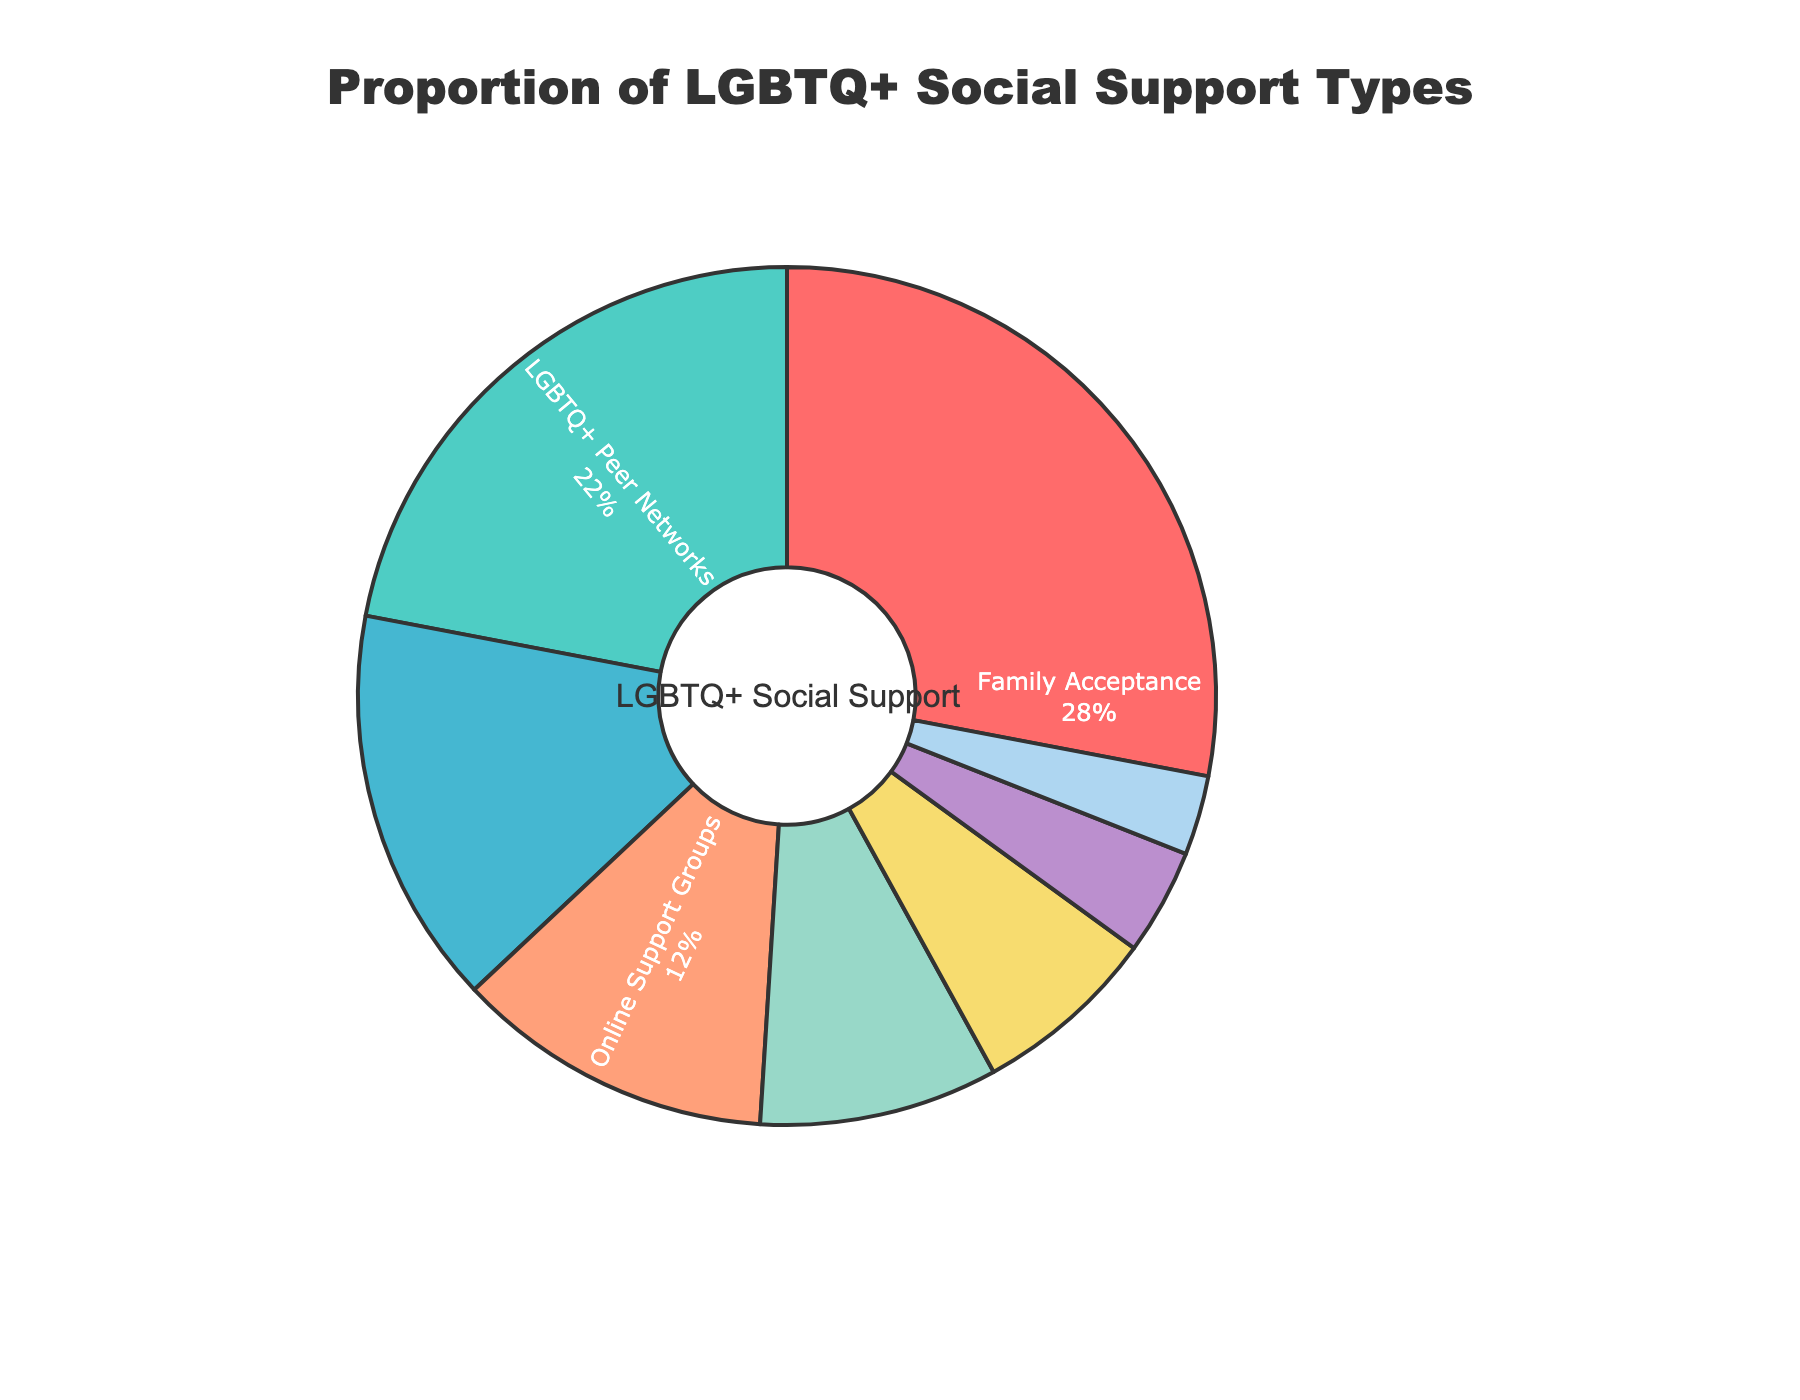What is the most common type of social support for LGBTQ+ individuals according to the pie chart? The slice of the pie chart representing "Family Acceptance" is the largest, indicating that it is the most prevalent form of social support.
Answer: Family Acceptance Which type of social support has the smallest proportion? The smallest slice of the pie chart represents "LGBTQ+ Youth Programs," indicating that it is the least common form of social support.
Answer: LGBTQ+ Youth Programs What is the combined percentage of LGBTQ+ individuals who receive support from LGBTQ+ Peer Networks and Community LGBTQ+ Centers? The percentage for LGBTQ+ Peer Networks is 22% and for Community LGBTQ+ Centers is 15%. Adding these two percentages together gives 22% + 15% = 37%.
Answer: 37% Is Family Acceptance more common than Online Support Groups and LGBTQ+ Affirming Workplaces combined? The percentage for Family Acceptance is 28%, while the sum of Online Support Groups (12%) and LGBTQ+ Affirming Workplaces (7%) is 12% + 7% = 19%. Since 28% is greater than 19%, Family Acceptance is more common.
Answer: Yes How does the proportion of individuals supported by LGBTQ+ Peer Networks compare to those supported by Supportive Healthcare Providers? LGBTQ+ Peer Networks have a proportion of 22%, while Supportive Healthcare Providers have a proportion of 9%. Since 22% is greater than 9%, LGBTQ+ Peer Networks have a higher proportion.
Answer: LGBTQ+ Peer Networks have a higher proportion What is the difference in the proportion of LGBTQ+ individuals supported by Online Support Groups and Supportive Healthcare Providers? The proportion of LGBTQ+ individuals supported by Online Support Groups is 12% and by Supportive Healthcare Providers is 9%. The difference is 12% - 9% = 3%.
Answer: 3% What percentage of LGBTQ+ individuals receive support from community-based resources (such as Community LGBTQ+ Centers and LGBTQ+ Youth Programs)? The percentage for Community LGBTQ+ Centers is 15% and for LGBTQ+ Youth Programs is 3%. Adding these together gives 15% + 3% = 18%.
Answer: 18% Among the listed types of social support, which two have the closest percentages? The percentages for Online Support Groups and Supportive Healthcare Providers are 12% and 9%, respectively. The difference between them is 3%, which is the smallest difference among all the listed types of social support.
Answer: Online Support Groups and Supportive Healthcare Providers Which social support types together account for more than half of the total support received by LGBTQ+ individuals? Family Acceptance (28%), LGBTQ+ Peer Networks (22%), and Community LGBTQ+ Centers (15%) are individual types, and their combined percentage is 28% + 22% + 15% = 65%. This is more than half the total support.
Answer: Family Acceptance, LGBTQ+ Peer Networks, and Community LGBTQ+ Centers 